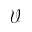Convert formula to latex. <formula><loc_0><loc_0><loc_500><loc_500>\mathcal { V }</formula> 